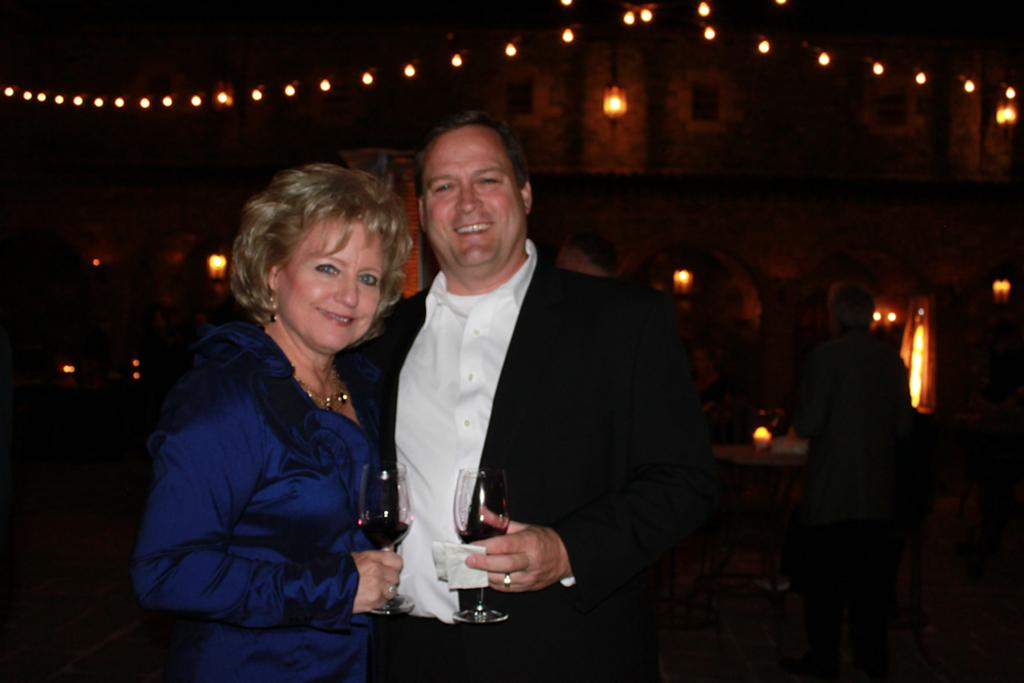How many people are in the image? There are two persons standing in the image. What are the expressions on their faces? The persons are smiling in the image. What are the persons holding in their hands? The persons are holding glasses in their hands. What can be seen in the background of the image? There are lights visible in the background of the image. What type of bait is the person on the left using in the image? There is no bait present in the image; the persons are holding glasses, not fishing equipment. Can you see a ray of light shining on the person on the right in the image? The provided facts do not mention a specific ray of light, so we cannot determine if one is shining on the person on the right. 